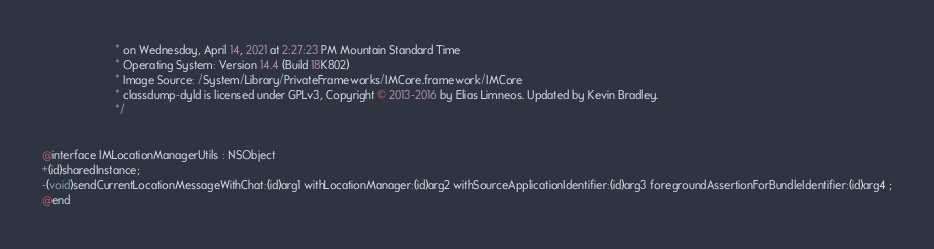Convert code to text. <code><loc_0><loc_0><loc_500><loc_500><_C_>                       * on Wednesday, April 14, 2021 at 2:27:23 PM Mountain Standard Time
                       * Operating System: Version 14.4 (Build 18K802)
                       * Image Source: /System/Library/PrivateFrameworks/IMCore.framework/IMCore
                       * classdump-dyld is licensed under GPLv3, Copyright © 2013-2016 by Elias Limneos. Updated by Kevin Bradley.
                       */


@interface IMLocationManagerUtils : NSObject
+(id)sharedInstance;
-(void)sendCurrentLocationMessageWithChat:(id)arg1 withLocationManager:(id)arg2 withSourceApplicationIdentifier:(id)arg3 foregroundAssertionForBundleIdentifier:(id)arg4 ;
@end

</code> 